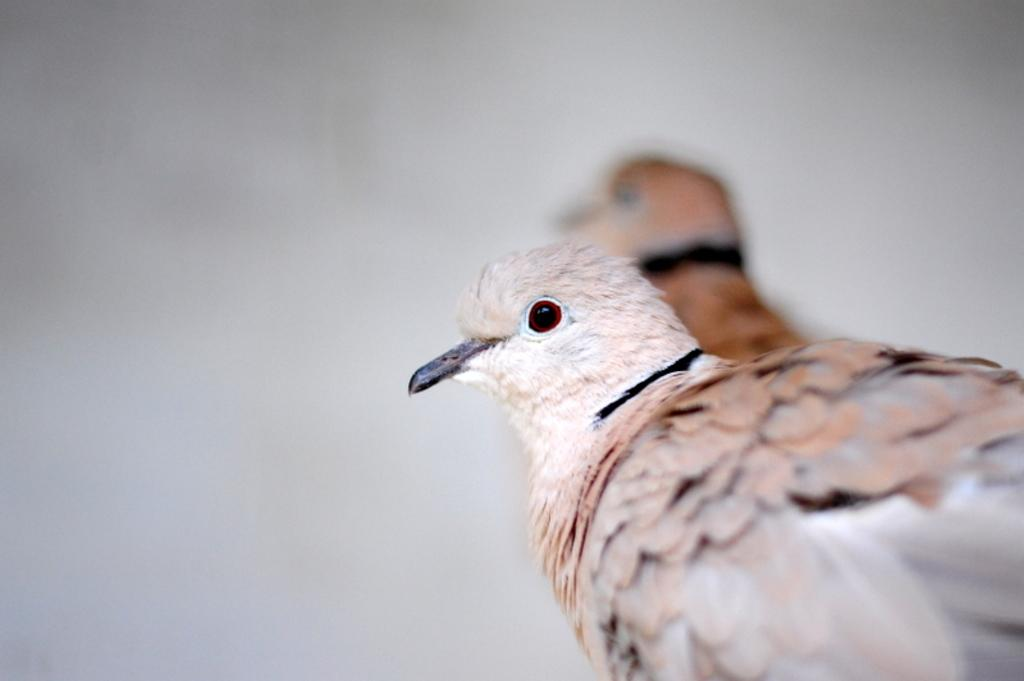How many birds are present in the image? There are two birds in the image. What can be observed about the background of the image? The background of the image is white. What type of fork is being used by the birds to teach each other in the image? There is no fork or teaching activity present in the image; it features two birds against a white background. 